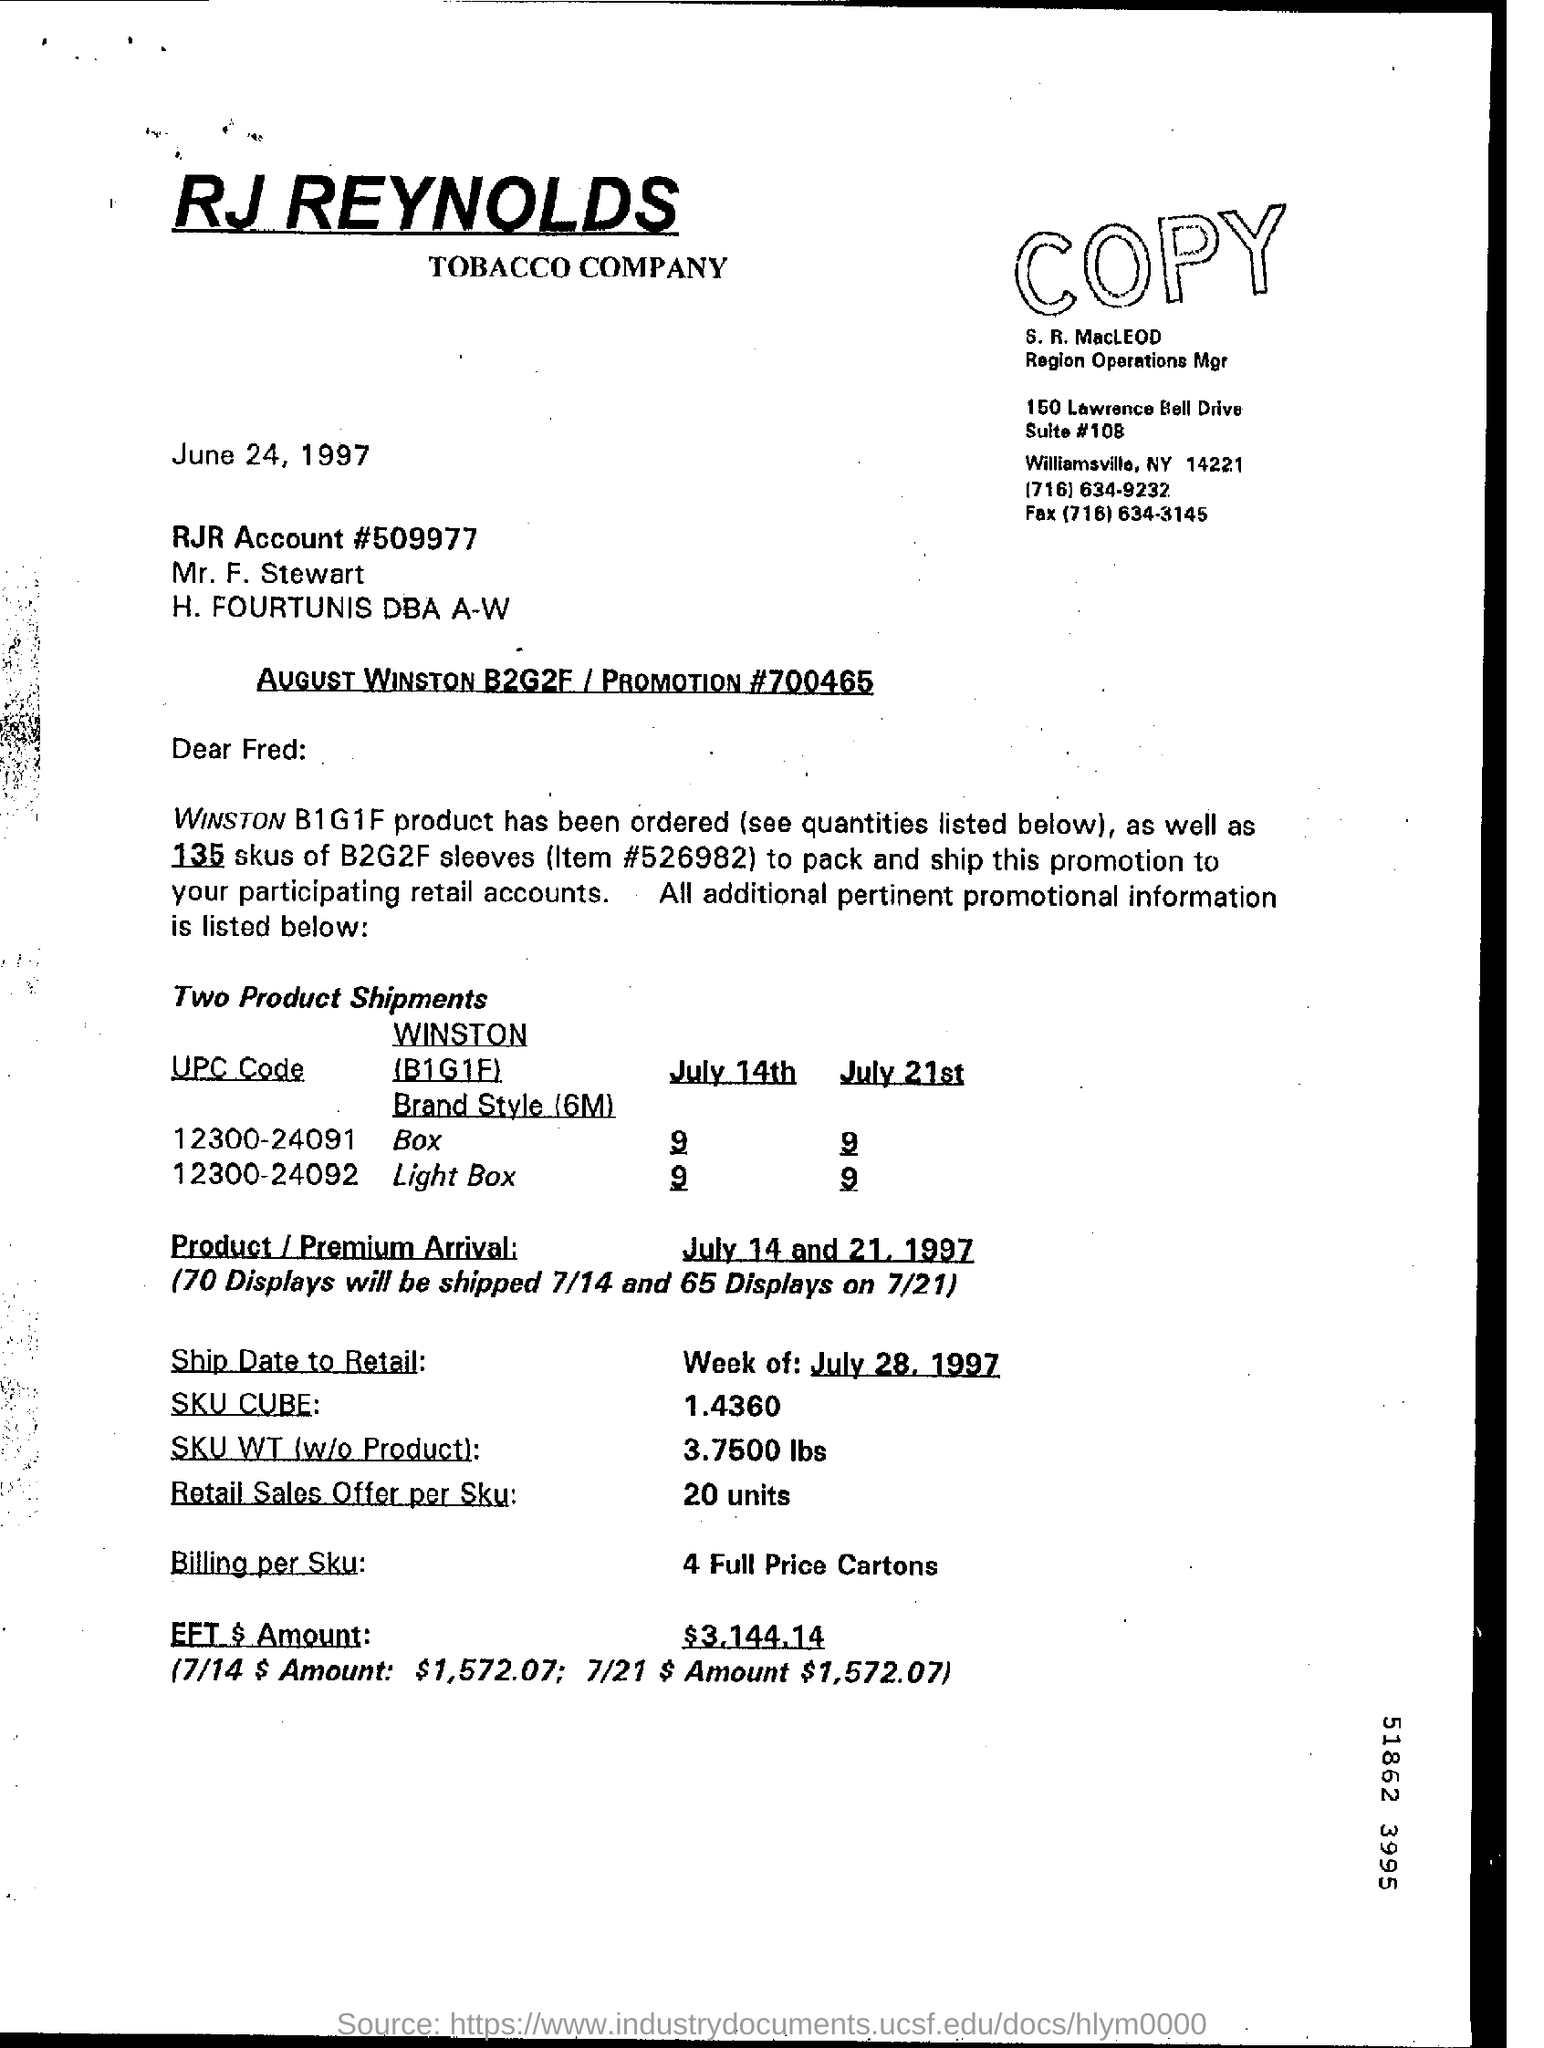To whom is the letter addressed?
Make the answer very short. Fred. What is the UPC Code of Winston (B1G1F) Brand style Light Box?
Keep it short and to the point. 12300-24092. How many displays will be shipped on 7/14?
Keep it short and to the point. 70. What is the SKU WT (w/o product)?
Ensure brevity in your answer.  3.7500 lbs. What is the Billing per SKU?
Your answer should be compact. 4 Full Price Cartons. When is the letter dated?
Offer a terse response. June 24 , 1997. 